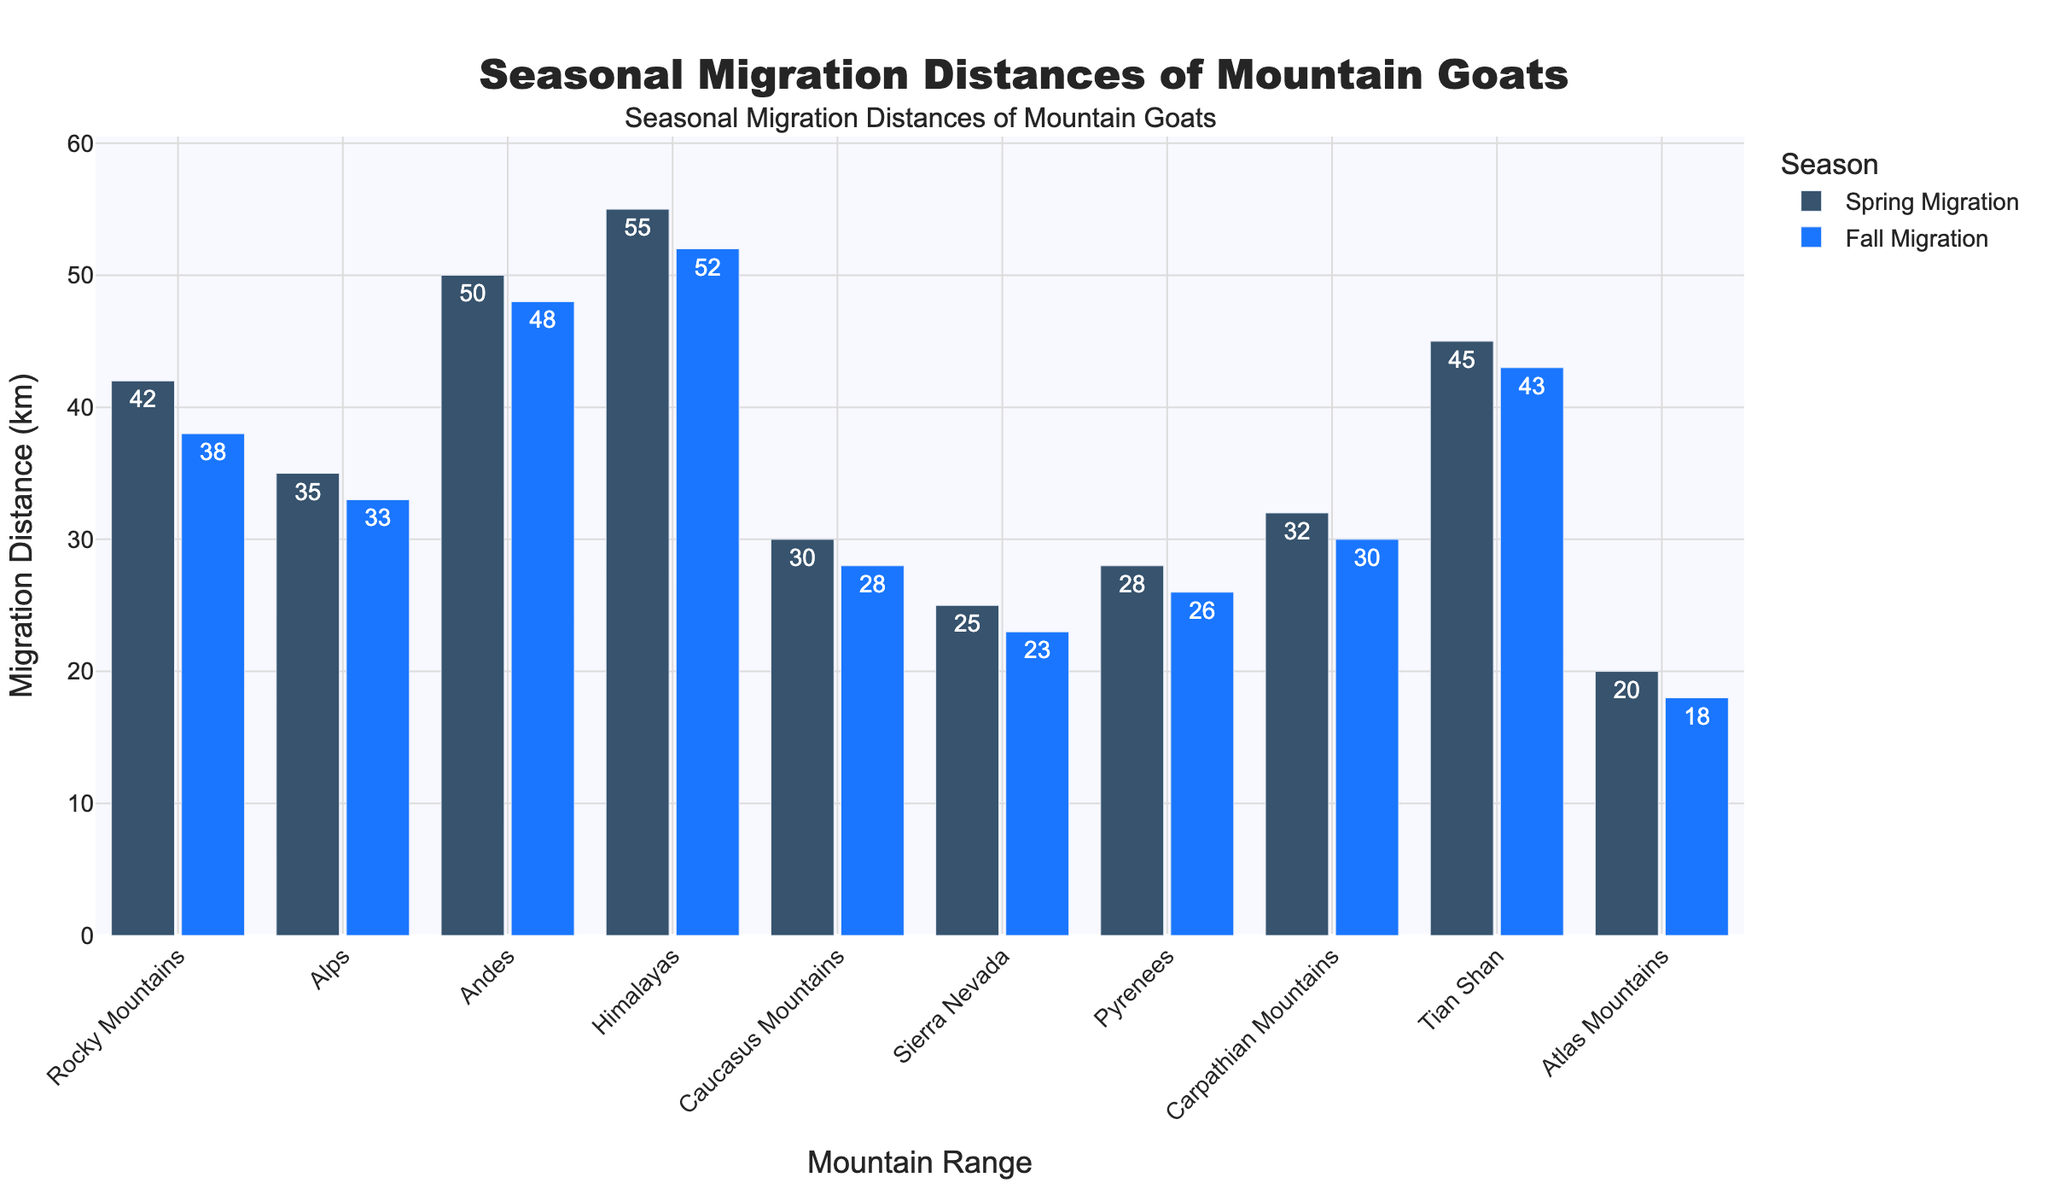What's the difference between the Spring and Fall migration distances in the Himalayas? First, identify the Spring migration distance in the Himalayas, which is 55 km, and the Fall migration distance, which is 52 km. The difference is 55 - 52.
Answer: 3 km Which mountain range has the highest Spring migration distance? Look at the bar heights or labels for Spring migration distances across all mountain ranges. The Himalayas have the highest value, which is 55 km.
Answer: Himalayas Which mountain range has a greater difference between Spring and Fall migration, the Tian Shan or the Carpathian Mountains? Calculate the difference for both ranges: Tian Shan = 45 - 43 = 2 km; Carpathian Mountains = 32 - 30 = 2 km. Both have the same difference.
Answer: Both have the same difference What is the average Spring migration distance across all mountain ranges? Sum all the Spring migration distances: 42 + 35 + 50 + 55 + 30 + 25 + 28 + 32 + 45 + 20 = 362 km. Divide by the number of ranges (10): 362 / 10.
Answer: 36.2 km Is the Fall migration distance in the Atlas Mountains less than the Spring migration distance in the Sierra Nevada? Compare the Fall migration distance in the Atlas Mountains (18 km) with the Spring migration distance in the Sierra Nevada (25 km).
Answer: Yes What is the total Fall migration distance covered by mountain goats in the Rockies, Alps, and Andes combined? Sum the Fall migration distances for these ranges: 38 (Rocky Mountains) + 33 (Alps) + 48 (Andes) = 119 km.
Answer: 119 km Which mountain range has the smallest Fall migration distance? Look for the smallest value in the Fall migration distances; the Atlas Mountains have the smallest value, which is 18 km.
Answer: Atlas Mountains Do the Rocky Mountains have a longer Spring or Fall migration distance? Compare the Spring (42 km) and Fall (38 km) migration distances for the Rocky Mountains.
Answer: Spring What is the range (the difference between the maximum and minimum values) of the Spring migration distances across all mountain ranges? Identify the maximum (55 km) and minimum (20 km) Spring migration distances. Subtract the minimum from the maximum: 55 - 20.
Answer: 35 km What's the total migration distance (Spring and Fall combined) for the Tian Shan mountain range? Add the Spring and Fall migration distances for the Tian Shan: 45 (Spring) + 43 (Fall) = 88 km.
Answer: 88 km 